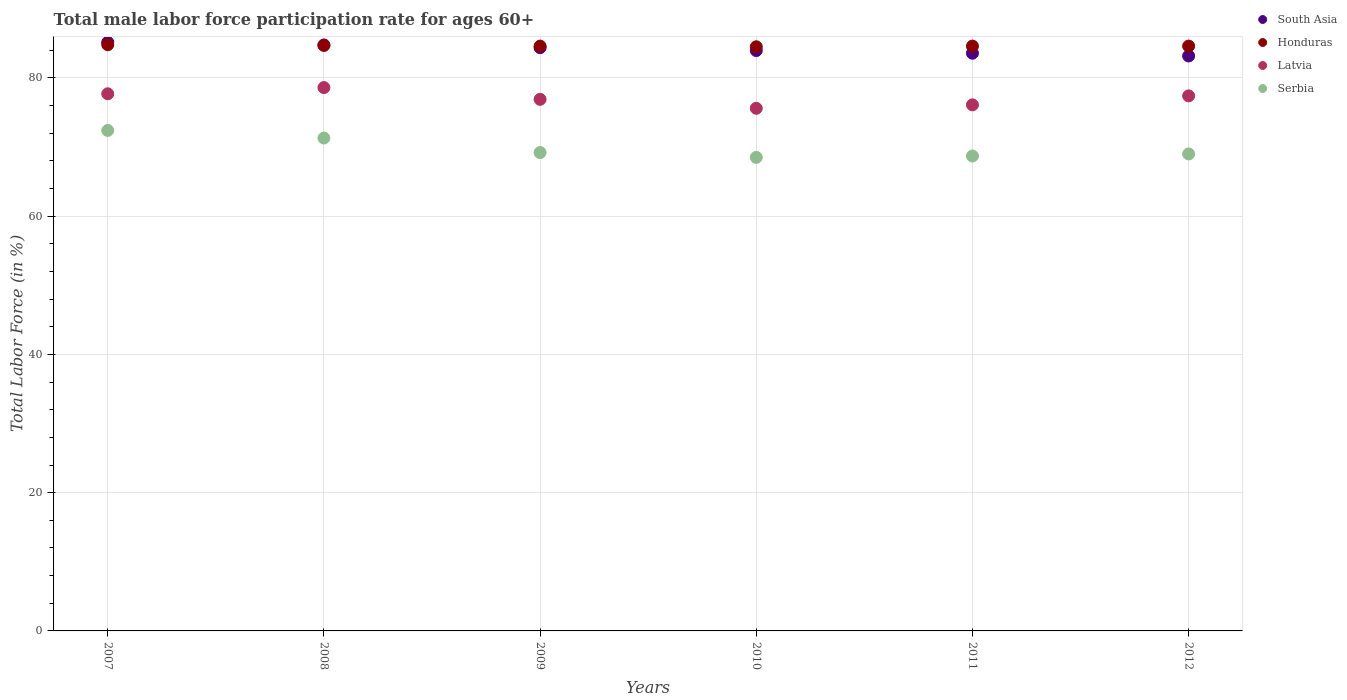How many different coloured dotlines are there?
Offer a very short reply. 4. What is the male labor force participation rate in South Asia in 2011?
Provide a short and direct response. 83.57. Across all years, what is the maximum male labor force participation rate in Serbia?
Offer a very short reply. 72.4. Across all years, what is the minimum male labor force participation rate in Latvia?
Your answer should be very brief. 75.6. In which year was the male labor force participation rate in Honduras maximum?
Provide a succinct answer. 2007. What is the total male labor force participation rate in Honduras in the graph?
Keep it short and to the point. 507.8. What is the difference between the male labor force participation rate in Latvia in 2009 and that in 2011?
Ensure brevity in your answer.  0.8. What is the difference between the male labor force participation rate in Latvia in 2012 and the male labor force participation rate in Serbia in 2010?
Make the answer very short. 8.9. What is the average male labor force participation rate in Honduras per year?
Give a very brief answer. 84.63. In the year 2007, what is the difference between the male labor force participation rate in Honduras and male labor force participation rate in Serbia?
Offer a very short reply. 12.4. In how many years, is the male labor force participation rate in Latvia greater than 36 %?
Your response must be concise. 6. What is the ratio of the male labor force participation rate in Serbia in 2008 to that in 2009?
Keep it short and to the point. 1.03. What is the difference between the highest and the second highest male labor force participation rate in South Asia?
Your answer should be compact. 0.38. In how many years, is the male labor force participation rate in South Asia greater than the average male labor force participation rate in South Asia taken over all years?
Give a very brief answer. 3. Is the sum of the male labor force participation rate in Latvia in 2007 and 2010 greater than the maximum male labor force participation rate in Serbia across all years?
Give a very brief answer. Yes. Is it the case that in every year, the sum of the male labor force participation rate in Latvia and male labor force participation rate in Honduras  is greater than the sum of male labor force participation rate in Serbia and male labor force participation rate in South Asia?
Provide a short and direct response. Yes. Does the male labor force participation rate in Latvia monotonically increase over the years?
Ensure brevity in your answer.  No. Is the male labor force participation rate in South Asia strictly greater than the male labor force participation rate in Latvia over the years?
Offer a terse response. Yes. How many dotlines are there?
Provide a short and direct response. 4. Are the values on the major ticks of Y-axis written in scientific E-notation?
Your response must be concise. No. Does the graph contain grids?
Give a very brief answer. Yes. Where does the legend appear in the graph?
Offer a very short reply. Top right. How are the legend labels stacked?
Offer a terse response. Vertical. What is the title of the graph?
Make the answer very short. Total male labor force participation rate for ages 60+. Does "Botswana" appear as one of the legend labels in the graph?
Keep it short and to the point. No. What is the label or title of the Y-axis?
Ensure brevity in your answer.  Total Labor Force (in %). What is the Total Labor Force (in %) in South Asia in 2007?
Keep it short and to the point. 85.14. What is the Total Labor Force (in %) in Honduras in 2007?
Provide a succinct answer. 84.8. What is the Total Labor Force (in %) in Latvia in 2007?
Keep it short and to the point. 77.7. What is the Total Labor Force (in %) in Serbia in 2007?
Ensure brevity in your answer.  72.4. What is the Total Labor Force (in %) of South Asia in 2008?
Offer a terse response. 84.77. What is the Total Labor Force (in %) in Honduras in 2008?
Provide a short and direct response. 84.7. What is the Total Labor Force (in %) in Latvia in 2008?
Offer a very short reply. 78.6. What is the Total Labor Force (in %) in Serbia in 2008?
Offer a very short reply. 71.3. What is the Total Labor Force (in %) of South Asia in 2009?
Keep it short and to the point. 84.37. What is the Total Labor Force (in %) in Honduras in 2009?
Your answer should be compact. 84.6. What is the Total Labor Force (in %) of Latvia in 2009?
Provide a succinct answer. 76.9. What is the Total Labor Force (in %) in Serbia in 2009?
Ensure brevity in your answer.  69.2. What is the Total Labor Force (in %) of South Asia in 2010?
Ensure brevity in your answer.  83.95. What is the Total Labor Force (in %) of Honduras in 2010?
Make the answer very short. 84.5. What is the Total Labor Force (in %) in Latvia in 2010?
Offer a terse response. 75.6. What is the Total Labor Force (in %) in Serbia in 2010?
Keep it short and to the point. 68.5. What is the Total Labor Force (in %) in South Asia in 2011?
Your answer should be very brief. 83.57. What is the Total Labor Force (in %) of Honduras in 2011?
Provide a short and direct response. 84.6. What is the Total Labor Force (in %) in Latvia in 2011?
Provide a succinct answer. 76.1. What is the Total Labor Force (in %) in Serbia in 2011?
Your answer should be very brief. 68.7. What is the Total Labor Force (in %) of South Asia in 2012?
Provide a succinct answer. 83.17. What is the Total Labor Force (in %) in Honduras in 2012?
Your response must be concise. 84.6. What is the Total Labor Force (in %) in Latvia in 2012?
Offer a very short reply. 77.4. What is the Total Labor Force (in %) of Serbia in 2012?
Offer a very short reply. 69. Across all years, what is the maximum Total Labor Force (in %) of South Asia?
Provide a succinct answer. 85.14. Across all years, what is the maximum Total Labor Force (in %) of Honduras?
Offer a terse response. 84.8. Across all years, what is the maximum Total Labor Force (in %) in Latvia?
Offer a terse response. 78.6. Across all years, what is the maximum Total Labor Force (in %) of Serbia?
Provide a succinct answer. 72.4. Across all years, what is the minimum Total Labor Force (in %) in South Asia?
Your response must be concise. 83.17. Across all years, what is the minimum Total Labor Force (in %) of Honduras?
Provide a short and direct response. 84.5. Across all years, what is the minimum Total Labor Force (in %) in Latvia?
Provide a succinct answer. 75.6. Across all years, what is the minimum Total Labor Force (in %) of Serbia?
Give a very brief answer. 68.5. What is the total Total Labor Force (in %) of South Asia in the graph?
Your answer should be compact. 504.97. What is the total Total Labor Force (in %) of Honduras in the graph?
Make the answer very short. 507.8. What is the total Total Labor Force (in %) in Latvia in the graph?
Give a very brief answer. 462.3. What is the total Total Labor Force (in %) in Serbia in the graph?
Provide a short and direct response. 419.1. What is the difference between the Total Labor Force (in %) in South Asia in 2007 and that in 2008?
Ensure brevity in your answer.  0.38. What is the difference between the Total Labor Force (in %) of Serbia in 2007 and that in 2008?
Ensure brevity in your answer.  1.1. What is the difference between the Total Labor Force (in %) in South Asia in 2007 and that in 2009?
Make the answer very short. 0.77. What is the difference between the Total Labor Force (in %) in Honduras in 2007 and that in 2009?
Provide a succinct answer. 0.2. What is the difference between the Total Labor Force (in %) of Latvia in 2007 and that in 2009?
Give a very brief answer. 0.8. What is the difference between the Total Labor Force (in %) of Serbia in 2007 and that in 2009?
Your answer should be compact. 3.2. What is the difference between the Total Labor Force (in %) in South Asia in 2007 and that in 2010?
Keep it short and to the point. 1.19. What is the difference between the Total Labor Force (in %) of Serbia in 2007 and that in 2010?
Your response must be concise. 3.9. What is the difference between the Total Labor Force (in %) of South Asia in 2007 and that in 2011?
Your answer should be compact. 1.58. What is the difference between the Total Labor Force (in %) in Honduras in 2007 and that in 2011?
Offer a very short reply. 0.2. What is the difference between the Total Labor Force (in %) of Latvia in 2007 and that in 2011?
Offer a terse response. 1.6. What is the difference between the Total Labor Force (in %) in Serbia in 2007 and that in 2011?
Give a very brief answer. 3.7. What is the difference between the Total Labor Force (in %) of South Asia in 2007 and that in 2012?
Your answer should be compact. 1.97. What is the difference between the Total Labor Force (in %) of Honduras in 2007 and that in 2012?
Your response must be concise. 0.2. What is the difference between the Total Labor Force (in %) in Latvia in 2007 and that in 2012?
Provide a succinct answer. 0.3. What is the difference between the Total Labor Force (in %) in Serbia in 2007 and that in 2012?
Give a very brief answer. 3.4. What is the difference between the Total Labor Force (in %) in South Asia in 2008 and that in 2009?
Your response must be concise. 0.39. What is the difference between the Total Labor Force (in %) in Honduras in 2008 and that in 2009?
Keep it short and to the point. 0.1. What is the difference between the Total Labor Force (in %) in Serbia in 2008 and that in 2009?
Keep it short and to the point. 2.1. What is the difference between the Total Labor Force (in %) of South Asia in 2008 and that in 2010?
Your answer should be very brief. 0.81. What is the difference between the Total Labor Force (in %) in South Asia in 2008 and that in 2011?
Offer a very short reply. 1.2. What is the difference between the Total Labor Force (in %) of Honduras in 2008 and that in 2011?
Provide a succinct answer. 0.1. What is the difference between the Total Labor Force (in %) in Serbia in 2008 and that in 2011?
Ensure brevity in your answer.  2.6. What is the difference between the Total Labor Force (in %) of South Asia in 2008 and that in 2012?
Offer a very short reply. 1.59. What is the difference between the Total Labor Force (in %) in Honduras in 2008 and that in 2012?
Your response must be concise. 0.1. What is the difference between the Total Labor Force (in %) in South Asia in 2009 and that in 2010?
Your response must be concise. 0.42. What is the difference between the Total Labor Force (in %) of Honduras in 2009 and that in 2010?
Provide a short and direct response. 0.1. What is the difference between the Total Labor Force (in %) of Latvia in 2009 and that in 2010?
Provide a short and direct response. 1.3. What is the difference between the Total Labor Force (in %) of Serbia in 2009 and that in 2010?
Your response must be concise. 0.7. What is the difference between the Total Labor Force (in %) of South Asia in 2009 and that in 2011?
Provide a succinct answer. 0.8. What is the difference between the Total Labor Force (in %) of Honduras in 2009 and that in 2011?
Your answer should be very brief. 0. What is the difference between the Total Labor Force (in %) in Serbia in 2009 and that in 2011?
Your answer should be very brief. 0.5. What is the difference between the Total Labor Force (in %) of South Asia in 2009 and that in 2012?
Your answer should be compact. 1.2. What is the difference between the Total Labor Force (in %) in Latvia in 2009 and that in 2012?
Your answer should be compact. -0.5. What is the difference between the Total Labor Force (in %) in South Asia in 2010 and that in 2011?
Your answer should be compact. 0.39. What is the difference between the Total Labor Force (in %) of Latvia in 2010 and that in 2011?
Your answer should be very brief. -0.5. What is the difference between the Total Labor Force (in %) of Serbia in 2010 and that in 2011?
Give a very brief answer. -0.2. What is the difference between the Total Labor Force (in %) in South Asia in 2010 and that in 2012?
Your answer should be very brief. 0.78. What is the difference between the Total Labor Force (in %) in Honduras in 2010 and that in 2012?
Your answer should be compact. -0.1. What is the difference between the Total Labor Force (in %) of South Asia in 2011 and that in 2012?
Your answer should be very brief. 0.4. What is the difference between the Total Labor Force (in %) in Honduras in 2011 and that in 2012?
Offer a very short reply. 0. What is the difference between the Total Labor Force (in %) of Latvia in 2011 and that in 2012?
Your response must be concise. -1.3. What is the difference between the Total Labor Force (in %) in Serbia in 2011 and that in 2012?
Give a very brief answer. -0.3. What is the difference between the Total Labor Force (in %) in South Asia in 2007 and the Total Labor Force (in %) in Honduras in 2008?
Your answer should be compact. 0.45. What is the difference between the Total Labor Force (in %) of South Asia in 2007 and the Total Labor Force (in %) of Latvia in 2008?
Your answer should be compact. 6.54. What is the difference between the Total Labor Force (in %) of South Asia in 2007 and the Total Labor Force (in %) of Serbia in 2008?
Keep it short and to the point. 13.85. What is the difference between the Total Labor Force (in %) of Honduras in 2007 and the Total Labor Force (in %) of Latvia in 2008?
Provide a short and direct response. 6.2. What is the difference between the Total Labor Force (in %) of Honduras in 2007 and the Total Labor Force (in %) of Serbia in 2008?
Make the answer very short. 13.5. What is the difference between the Total Labor Force (in %) in Latvia in 2007 and the Total Labor Force (in %) in Serbia in 2008?
Make the answer very short. 6.4. What is the difference between the Total Labor Force (in %) in South Asia in 2007 and the Total Labor Force (in %) in Honduras in 2009?
Your answer should be compact. 0.55. What is the difference between the Total Labor Force (in %) in South Asia in 2007 and the Total Labor Force (in %) in Latvia in 2009?
Your response must be concise. 8.24. What is the difference between the Total Labor Force (in %) in South Asia in 2007 and the Total Labor Force (in %) in Serbia in 2009?
Ensure brevity in your answer.  15.95. What is the difference between the Total Labor Force (in %) in Honduras in 2007 and the Total Labor Force (in %) in Latvia in 2009?
Your answer should be compact. 7.9. What is the difference between the Total Labor Force (in %) in Honduras in 2007 and the Total Labor Force (in %) in Serbia in 2009?
Offer a terse response. 15.6. What is the difference between the Total Labor Force (in %) in Latvia in 2007 and the Total Labor Force (in %) in Serbia in 2009?
Offer a very short reply. 8.5. What is the difference between the Total Labor Force (in %) in South Asia in 2007 and the Total Labor Force (in %) in Honduras in 2010?
Offer a terse response. 0.65. What is the difference between the Total Labor Force (in %) in South Asia in 2007 and the Total Labor Force (in %) in Latvia in 2010?
Your response must be concise. 9.54. What is the difference between the Total Labor Force (in %) in South Asia in 2007 and the Total Labor Force (in %) in Serbia in 2010?
Keep it short and to the point. 16.64. What is the difference between the Total Labor Force (in %) in Honduras in 2007 and the Total Labor Force (in %) in Latvia in 2010?
Your response must be concise. 9.2. What is the difference between the Total Labor Force (in %) of South Asia in 2007 and the Total Labor Force (in %) of Honduras in 2011?
Provide a short and direct response. 0.55. What is the difference between the Total Labor Force (in %) in South Asia in 2007 and the Total Labor Force (in %) in Latvia in 2011?
Provide a short and direct response. 9.04. What is the difference between the Total Labor Force (in %) of South Asia in 2007 and the Total Labor Force (in %) of Serbia in 2011?
Give a very brief answer. 16.45. What is the difference between the Total Labor Force (in %) in Honduras in 2007 and the Total Labor Force (in %) in Latvia in 2011?
Give a very brief answer. 8.7. What is the difference between the Total Labor Force (in %) of Honduras in 2007 and the Total Labor Force (in %) of Serbia in 2011?
Offer a terse response. 16.1. What is the difference between the Total Labor Force (in %) of South Asia in 2007 and the Total Labor Force (in %) of Honduras in 2012?
Your answer should be compact. 0.55. What is the difference between the Total Labor Force (in %) of South Asia in 2007 and the Total Labor Force (in %) of Latvia in 2012?
Your answer should be compact. 7.75. What is the difference between the Total Labor Force (in %) in South Asia in 2007 and the Total Labor Force (in %) in Serbia in 2012?
Offer a terse response. 16.14. What is the difference between the Total Labor Force (in %) in Honduras in 2007 and the Total Labor Force (in %) in Latvia in 2012?
Offer a very short reply. 7.4. What is the difference between the Total Labor Force (in %) of Honduras in 2007 and the Total Labor Force (in %) of Serbia in 2012?
Offer a very short reply. 15.8. What is the difference between the Total Labor Force (in %) in Latvia in 2007 and the Total Labor Force (in %) in Serbia in 2012?
Provide a short and direct response. 8.7. What is the difference between the Total Labor Force (in %) in South Asia in 2008 and the Total Labor Force (in %) in Honduras in 2009?
Provide a short and direct response. 0.17. What is the difference between the Total Labor Force (in %) of South Asia in 2008 and the Total Labor Force (in %) of Latvia in 2009?
Provide a short and direct response. 7.87. What is the difference between the Total Labor Force (in %) in South Asia in 2008 and the Total Labor Force (in %) in Serbia in 2009?
Offer a terse response. 15.57. What is the difference between the Total Labor Force (in %) in Honduras in 2008 and the Total Labor Force (in %) in Latvia in 2009?
Give a very brief answer. 7.8. What is the difference between the Total Labor Force (in %) of Honduras in 2008 and the Total Labor Force (in %) of Serbia in 2009?
Provide a short and direct response. 15.5. What is the difference between the Total Labor Force (in %) in South Asia in 2008 and the Total Labor Force (in %) in Honduras in 2010?
Ensure brevity in your answer.  0.27. What is the difference between the Total Labor Force (in %) in South Asia in 2008 and the Total Labor Force (in %) in Latvia in 2010?
Give a very brief answer. 9.17. What is the difference between the Total Labor Force (in %) in South Asia in 2008 and the Total Labor Force (in %) in Serbia in 2010?
Provide a succinct answer. 16.27. What is the difference between the Total Labor Force (in %) in Honduras in 2008 and the Total Labor Force (in %) in Latvia in 2010?
Keep it short and to the point. 9.1. What is the difference between the Total Labor Force (in %) in South Asia in 2008 and the Total Labor Force (in %) in Honduras in 2011?
Your answer should be very brief. 0.17. What is the difference between the Total Labor Force (in %) in South Asia in 2008 and the Total Labor Force (in %) in Latvia in 2011?
Your answer should be compact. 8.67. What is the difference between the Total Labor Force (in %) of South Asia in 2008 and the Total Labor Force (in %) of Serbia in 2011?
Your answer should be very brief. 16.07. What is the difference between the Total Labor Force (in %) in Latvia in 2008 and the Total Labor Force (in %) in Serbia in 2011?
Your answer should be very brief. 9.9. What is the difference between the Total Labor Force (in %) of South Asia in 2008 and the Total Labor Force (in %) of Honduras in 2012?
Keep it short and to the point. 0.17. What is the difference between the Total Labor Force (in %) in South Asia in 2008 and the Total Labor Force (in %) in Latvia in 2012?
Offer a terse response. 7.37. What is the difference between the Total Labor Force (in %) in South Asia in 2008 and the Total Labor Force (in %) in Serbia in 2012?
Your answer should be very brief. 15.77. What is the difference between the Total Labor Force (in %) of South Asia in 2009 and the Total Labor Force (in %) of Honduras in 2010?
Give a very brief answer. -0.13. What is the difference between the Total Labor Force (in %) of South Asia in 2009 and the Total Labor Force (in %) of Latvia in 2010?
Offer a terse response. 8.77. What is the difference between the Total Labor Force (in %) in South Asia in 2009 and the Total Labor Force (in %) in Serbia in 2010?
Offer a very short reply. 15.87. What is the difference between the Total Labor Force (in %) of Honduras in 2009 and the Total Labor Force (in %) of Serbia in 2010?
Your answer should be very brief. 16.1. What is the difference between the Total Labor Force (in %) in Latvia in 2009 and the Total Labor Force (in %) in Serbia in 2010?
Your answer should be very brief. 8.4. What is the difference between the Total Labor Force (in %) of South Asia in 2009 and the Total Labor Force (in %) of Honduras in 2011?
Your response must be concise. -0.23. What is the difference between the Total Labor Force (in %) in South Asia in 2009 and the Total Labor Force (in %) in Latvia in 2011?
Offer a very short reply. 8.27. What is the difference between the Total Labor Force (in %) in South Asia in 2009 and the Total Labor Force (in %) in Serbia in 2011?
Make the answer very short. 15.67. What is the difference between the Total Labor Force (in %) of Honduras in 2009 and the Total Labor Force (in %) of Latvia in 2011?
Provide a succinct answer. 8.5. What is the difference between the Total Labor Force (in %) of Honduras in 2009 and the Total Labor Force (in %) of Serbia in 2011?
Keep it short and to the point. 15.9. What is the difference between the Total Labor Force (in %) in Latvia in 2009 and the Total Labor Force (in %) in Serbia in 2011?
Your answer should be compact. 8.2. What is the difference between the Total Labor Force (in %) of South Asia in 2009 and the Total Labor Force (in %) of Honduras in 2012?
Your answer should be compact. -0.23. What is the difference between the Total Labor Force (in %) in South Asia in 2009 and the Total Labor Force (in %) in Latvia in 2012?
Your response must be concise. 6.97. What is the difference between the Total Labor Force (in %) in South Asia in 2009 and the Total Labor Force (in %) in Serbia in 2012?
Your answer should be compact. 15.37. What is the difference between the Total Labor Force (in %) of South Asia in 2010 and the Total Labor Force (in %) of Honduras in 2011?
Your answer should be compact. -0.65. What is the difference between the Total Labor Force (in %) of South Asia in 2010 and the Total Labor Force (in %) of Latvia in 2011?
Offer a very short reply. 7.85. What is the difference between the Total Labor Force (in %) of South Asia in 2010 and the Total Labor Force (in %) of Serbia in 2011?
Offer a very short reply. 15.25. What is the difference between the Total Labor Force (in %) of Honduras in 2010 and the Total Labor Force (in %) of Serbia in 2011?
Provide a short and direct response. 15.8. What is the difference between the Total Labor Force (in %) in Latvia in 2010 and the Total Labor Force (in %) in Serbia in 2011?
Give a very brief answer. 6.9. What is the difference between the Total Labor Force (in %) in South Asia in 2010 and the Total Labor Force (in %) in Honduras in 2012?
Provide a succinct answer. -0.65. What is the difference between the Total Labor Force (in %) in South Asia in 2010 and the Total Labor Force (in %) in Latvia in 2012?
Your response must be concise. 6.55. What is the difference between the Total Labor Force (in %) in South Asia in 2010 and the Total Labor Force (in %) in Serbia in 2012?
Your answer should be compact. 14.95. What is the difference between the Total Labor Force (in %) in Honduras in 2010 and the Total Labor Force (in %) in Serbia in 2012?
Make the answer very short. 15.5. What is the difference between the Total Labor Force (in %) of South Asia in 2011 and the Total Labor Force (in %) of Honduras in 2012?
Ensure brevity in your answer.  -1.03. What is the difference between the Total Labor Force (in %) of South Asia in 2011 and the Total Labor Force (in %) of Latvia in 2012?
Offer a very short reply. 6.17. What is the difference between the Total Labor Force (in %) in South Asia in 2011 and the Total Labor Force (in %) in Serbia in 2012?
Offer a very short reply. 14.57. What is the difference between the Total Labor Force (in %) of Latvia in 2011 and the Total Labor Force (in %) of Serbia in 2012?
Your answer should be very brief. 7.1. What is the average Total Labor Force (in %) of South Asia per year?
Keep it short and to the point. 84.16. What is the average Total Labor Force (in %) of Honduras per year?
Your response must be concise. 84.63. What is the average Total Labor Force (in %) of Latvia per year?
Give a very brief answer. 77.05. What is the average Total Labor Force (in %) of Serbia per year?
Provide a succinct answer. 69.85. In the year 2007, what is the difference between the Total Labor Force (in %) in South Asia and Total Labor Force (in %) in Honduras?
Offer a terse response. 0.34. In the year 2007, what is the difference between the Total Labor Force (in %) of South Asia and Total Labor Force (in %) of Latvia?
Offer a terse response. 7.45. In the year 2007, what is the difference between the Total Labor Force (in %) in South Asia and Total Labor Force (in %) in Serbia?
Your answer should be compact. 12.74. In the year 2007, what is the difference between the Total Labor Force (in %) of Honduras and Total Labor Force (in %) of Latvia?
Provide a short and direct response. 7.1. In the year 2007, what is the difference between the Total Labor Force (in %) in Honduras and Total Labor Force (in %) in Serbia?
Your response must be concise. 12.4. In the year 2008, what is the difference between the Total Labor Force (in %) in South Asia and Total Labor Force (in %) in Honduras?
Your answer should be very brief. 0.07. In the year 2008, what is the difference between the Total Labor Force (in %) in South Asia and Total Labor Force (in %) in Latvia?
Your answer should be very brief. 6.17. In the year 2008, what is the difference between the Total Labor Force (in %) of South Asia and Total Labor Force (in %) of Serbia?
Ensure brevity in your answer.  13.47. In the year 2008, what is the difference between the Total Labor Force (in %) of Honduras and Total Labor Force (in %) of Serbia?
Ensure brevity in your answer.  13.4. In the year 2008, what is the difference between the Total Labor Force (in %) in Latvia and Total Labor Force (in %) in Serbia?
Offer a very short reply. 7.3. In the year 2009, what is the difference between the Total Labor Force (in %) in South Asia and Total Labor Force (in %) in Honduras?
Offer a terse response. -0.23. In the year 2009, what is the difference between the Total Labor Force (in %) in South Asia and Total Labor Force (in %) in Latvia?
Keep it short and to the point. 7.47. In the year 2009, what is the difference between the Total Labor Force (in %) of South Asia and Total Labor Force (in %) of Serbia?
Your answer should be compact. 15.17. In the year 2009, what is the difference between the Total Labor Force (in %) in Honduras and Total Labor Force (in %) in Latvia?
Provide a succinct answer. 7.7. In the year 2010, what is the difference between the Total Labor Force (in %) in South Asia and Total Labor Force (in %) in Honduras?
Offer a very short reply. -0.55. In the year 2010, what is the difference between the Total Labor Force (in %) in South Asia and Total Labor Force (in %) in Latvia?
Your answer should be very brief. 8.35. In the year 2010, what is the difference between the Total Labor Force (in %) in South Asia and Total Labor Force (in %) in Serbia?
Give a very brief answer. 15.45. In the year 2010, what is the difference between the Total Labor Force (in %) of Honduras and Total Labor Force (in %) of Latvia?
Make the answer very short. 8.9. In the year 2010, what is the difference between the Total Labor Force (in %) of Honduras and Total Labor Force (in %) of Serbia?
Ensure brevity in your answer.  16. In the year 2011, what is the difference between the Total Labor Force (in %) in South Asia and Total Labor Force (in %) in Honduras?
Offer a very short reply. -1.03. In the year 2011, what is the difference between the Total Labor Force (in %) of South Asia and Total Labor Force (in %) of Latvia?
Make the answer very short. 7.47. In the year 2011, what is the difference between the Total Labor Force (in %) of South Asia and Total Labor Force (in %) of Serbia?
Your answer should be compact. 14.87. In the year 2011, what is the difference between the Total Labor Force (in %) in Honduras and Total Labor Force (in %) in Serbia?
Make the answer very short. 15.9. In the year 2012, what is the difference between the Total Labor Force (in %) of South Asia and Total Labor Force (in %) of Honduras?
Ensure brevity in your answer.  -1.43. In the year 2012, what is the difference between the Total Labor Force (in %) in South Asia and Total Labor Force (in %) in Latvia?
Offer a terse response. 5.77. In the year 2012, what is the difference between the Total Labor Force (in %) in South Asia and Total Labor Force (in %) in Serbia?
Ensure brevity in your answer.  14.17. In the year 2012, what is the difference between the Total Labor Force (in %) of Honduras and Total Labor Force (in %) of Latvia?
Provide a short and direct response. 7.2. In the year 2012, what is the difference between the Total Labor Force (in %) of Honduras and Total Labor Force (in %) of Serbia?
Provide a succinct answer. 15.6. In the year 2012, what is the difference between the Total Labor Force (in %) of Latvia and Total Labor Force (in %) of Serbia?
Provide a short and direct response. 8.4. What is the ratio of the Total Labor Force (in %) in Latvia in 2007 to that in 2008?
Give a very brief answer. 0.99. What is the ratio of the Total Labor Force (in %) of Serbia in 2007 to that in 2008?
Your answer should be compact. 1.02. What is the ratio of the Total Labor Force (in %) in South Asia in 2007 to that in 2009?
Ensure brevity in your answer.  1.01. What is the ratio of the Total Labor Force (in %) of Latvia in 2007 to that in 2009?
Keep it short and to the point. 1.01. What is the ratio of the Total Labor Force (in %) of Serbia in 2007 to that in 2009?
Offer a terse response. 1.05. What is the ratio of the Total Labor Force (in %) of South Asia in 2007 to that in 2010?
Your response must be concise. 1.01. What is the ratio of the Total Labor Force (in %) of Honduras in 2007 to that in 2010?
Ensure brevity in your answer.  1. What is the ratio of the Total Labor Force (in %) of Latvia in 2007 to that in 2010?
Give a very brief answer. 1.03. What is the ratio of the Total Labor Force (in %) in Serbia in 2007 to that in 2010?
Ensure brevity in your answer.  1.06. What is the ratio of the Total Labor Force (in %) in South Asia in 2007 to that in 2011?
Offer a terse response. 1.02. What is the ratio of the Total Labor Force (in %) of Latvia in 2007 to that in 2011?
Your answer should be compact. 1.02. What is the ratio of the Total Labor Force (in %) in Serbia in 2007 to that in 2011?
Give a very brief answer. 1.05. What is the ratio of the Total Labor Force (in %) of South Asia in 2007 to that in 2012?
Your answer should be compact. 1.02. What is the ratio of the Total Labor Force (in %) of Honduras in 2007 to that in 2012?
Offer a very short reply. 1. What is the ratio of the Total Labor Force (in %) in Serbia in 2007 to that in 2012?
Offer a terse response. 1.05. What is the ratio of the Total Labor Force (in %) in South Asia in 2008 to that in 2009?
Ensure brevity in your answer.  1. What is the ratio of the Total Labor Force (in %) in Honduras in 2008 to that in 2009?
Give a very brief answer. 1. What is the ratio of the Total Labor Force (in %) in Latvia in 2008 to that in 2009?
Make the answer very short. 1.02. What is the ratio of the Total Labor Force (in %) in Serbia in 2008 to that in 2009?
Provide a succinct answer. 1.03. What is the ratio of the Total Labor Force (in %) of South Asia in 2008 to that in 2010?
Make the answer very short. 1.01. What is the ratio of the Total Labor Force (in %) in Honduras in 2008 to that in 2010?
Offer a terse response. 1. What is the ratio of the Total Labor Force (in %) of Latvia in 2008 to that in 2010?
Your response must be concise. 1.04. What is the ratio of the Total Labor Force (in %) of Serbia in 2008 to that in 2010?
Your answer should be compact. 1.04. What is the ratio of the Total Labor Force (in %) of South Asia in 2008 to that in 2011?
Provide a succinct answer. 1.01. What is the ratio of the Total Labor Force (in %) of Honduras in 2008 to that in 2011?
Keep it short and to the point. 1. What is the ratio of the Total Labor Force (in %) of Latvia in 2008 to that in 2011?
Your response must be concise. 1.03. What is the ratio of the Total Labor Force (in %) in Serbia in 2008 to that in 2011?
Ensure brevity in your answer.  1.04. What is the ratio of the Total Labor Force (in %) in South Asia in 2008 to that in 2012?
Your answer should be compact. 1.02. What is the ratio of the Total Labor Force (in %) of Honduras in 2008 to that in 2012?
Keep it short and to the point. 1. What is the ratio of the Total Labor Force (in %) in Latvia in 2008 to that in 2012?
Offer a very short reply. 1.02. What is the ratio of the Total Labor Force (in %) in South Asia in 2009 to that in 2010?
Give a very brief answer. 1. What is the ratio of the Total Labor Force (in %) of Latvia in 2009 to that in 2010?
Your answer should be very brief. 1.02. What is the ratio of the Total Labor Force (in %) of Serbia in 2009 to that in 2010?
Your response must be concise. 1.01. What is the ratio of the Total Labor Force (in %) in South Asia in 2009 to that in 2011?
Your answer should be compact. 1.01. What is the ratio of the Total Labor Force (in %) in Honduras in 2009 to that in 2011?
Provide a succinct answer. 1. What is the ratio of the Total Labor Force (in %) in Latvia in 2009 to that in 2011?
Offer a very short reply. 1.01. What is the ratio of the Total Labor Force (in %) in Serbia in 2009 to that in 2011?
Keep it short and to the point. 1.01. What is the ratio of the Total Labor Force (in %) in South Asia in 2009 to that in 2012?
Provide a short and direct response. 1.01. What is the ratio of the Total Labor Force (in %) in Latvia in 2009 to that in 2012?
Provide a short and direct response. 0.99. What is the ratio of the Total Labor Force (in %) of South Asia in 2010 to that in 2011?
Your answer should be very brief. 1. What is the ratio of the Total Labor Force (in %) in Latvia in 2010 to that in 2011?
Your answer should be compact. 0.99. What is the ratio of the Total Labor Force (in %) in Serbia in 2010 to that in 2011?
Make the answer very short. 1. What is the ratio of the Total Labor Force (in %) in South Asia in 2010 to that in 2012?
Give a very brief answer. 1.01. What is the ratio of the Total Labor Force (in %) of Honduras in 2010 to that in 2012?
Ensure brevity in your answer.  1. What is the ratio of the Total Labor Force (in %) in Latvia in 2010 to that in 2012?
Your response must be concise. 0.98. What is the ratio of the Total Labor Force (in %) in South Asia in 2011 to that in 2012?
Your answer should be very brief. 1. What is the ratio of the Total Labor Force (in %) of Honduras in 2011 to that in 2012?
Provide a succinct answer. 1. What is the ratio of the Total Labor Force (in %) in Latvia in 2011 to that in 2012?
Keep it short and to the point. 0.98. What is the ratio of the Total Labor Force (in %) of Serbia in 2011 to that in 2012?
Offer a very short reply. 1. What is the difference between the highest and the second highest Total Labor Force (in %) in South Asia?
Provide a succinct answer. 0.38. What is the difference between the highest and the second highest Total Labor Force (in %) in Latvia?
Your response must be concise. 0.9. What is the difference between the highest and the lowest Total Labor Force (in %) in South Asia?
Provide a short and direct response. 1.97. What is the difference between the highest and the lowest Total Labor Force (in %) of Serbia?
Your response must be concise. 3.9. 